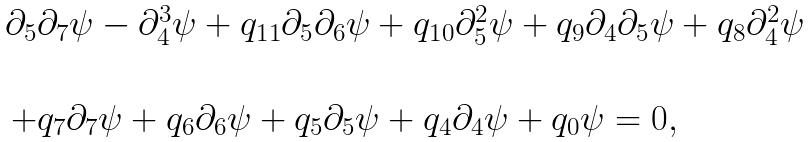Convert formula to latex. <formula><loc_0><loc_0><loc_500><loc_500>\begin{array} { l } \partial _ { 5 } \partial _ { 7 } \psi - \partial _ { 4 } ^ { 3 } \psi + q _ { 1 1 } \partial _ { 5 } \partial _ { 6 } \psi + q _ { 1 0 } \partial _ { 5 } ^ { 2 } \psi + q _ { 9 } \partial _ { 4 } \partial _ { 5 } \psi + q _ { 8 } \partial _ { 4 } ^ { 2 } \psi \\ \\ \, + q _ { 7 } \partial _ { 7 } \psi + q _ { 6 } \partial _ { 6 } \psi + q _ { 5 } \partial _ { 5 } \psi + q _ { 4 } \partial _ { 4 } \psi + q _ { 0 } \psi = 0 , \end{array}</formula> 